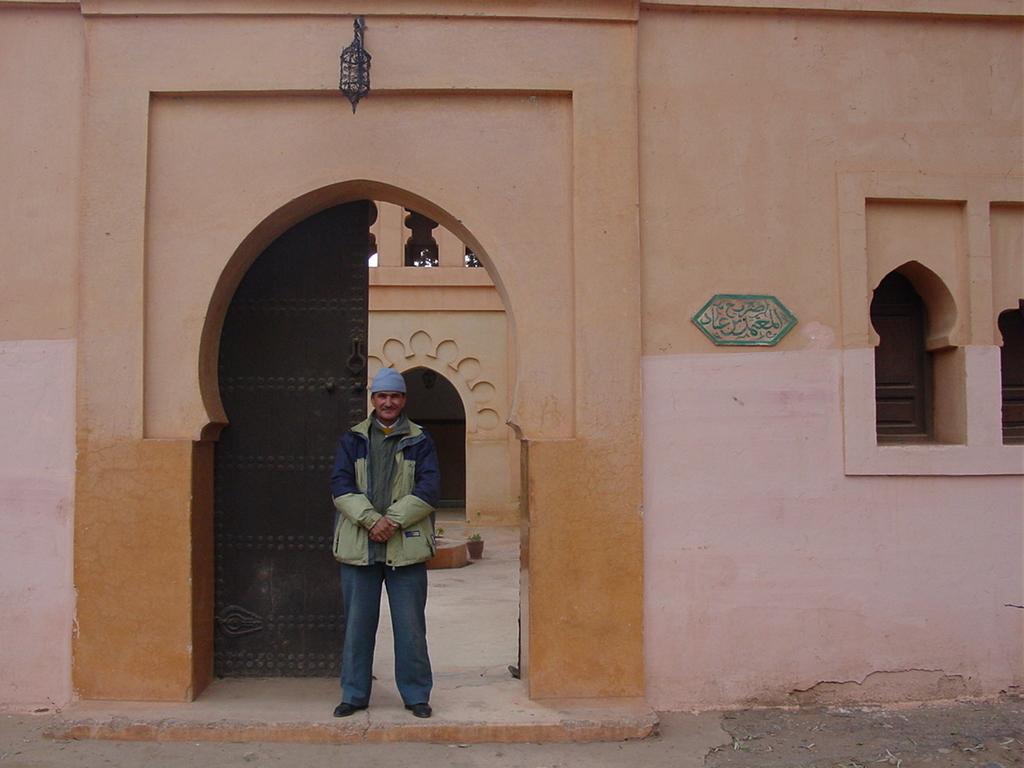Could you give a brief overview of what you see in this image? In the center of the image there is a person standing. In the background of the image there is wall. There is a gate. At the bottom of the image there is road. To the right side of the image there are windows. 